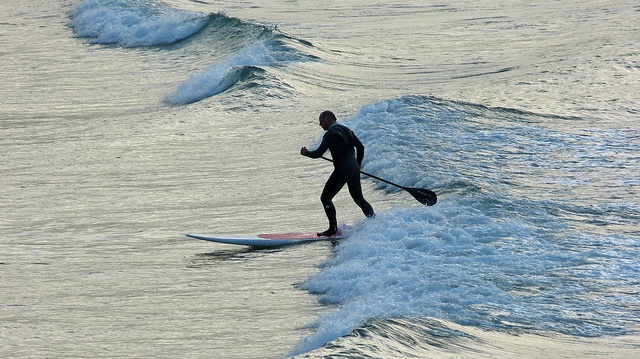Describe the objects in this image and their specific colors. I can see people in darkgray, black, and gray tones and surfboard in darkgray, lightgray, and gray tones in this image. 